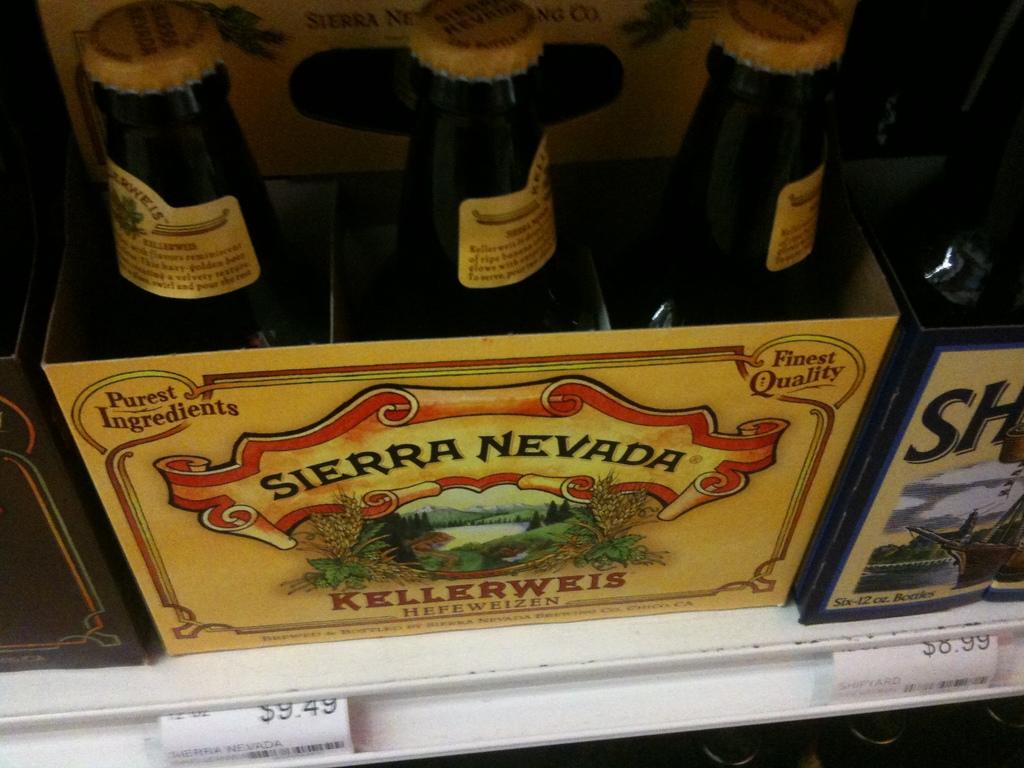Is kellerweis a beer from germany?
Offer a very short reply. Yes. 